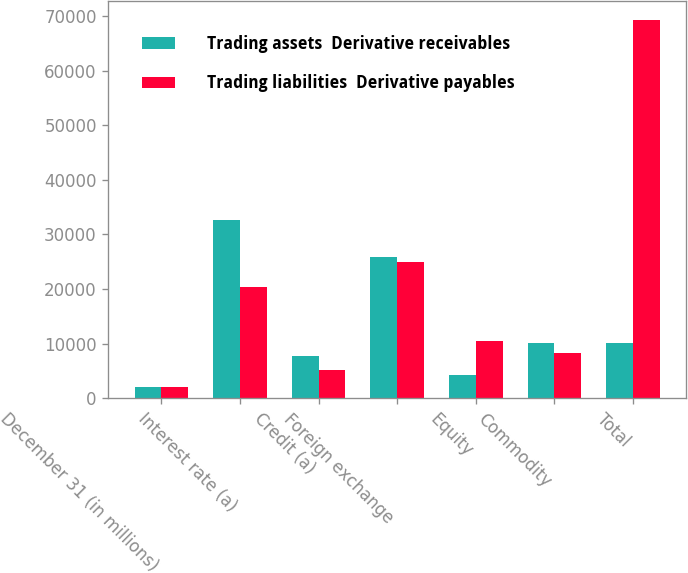Convert chart. <chart><loc_0><loc_0><loc_500><loc_500><stacked_bar_chart><ecel><fcel>December 31 (in millions)<fcel>Interest rate (a)<fcel>Credit (a)<fcel>Foreign exchange<fcel>Equity<fcel>Commodity<fcel>Total<nl><fcel>Trading assets  Derivative receivables<fcel>2010<fcel>32555<fcel>7725<fcel>25858<fcel>4204<fcel>10139<fcel>10139<nl><fcel>Trading liabilities  Derivative payables<fcel>2010<fcel>20387<fcel>5138<fcel>25015<fcel>10450<fcel>8229<fcel>69219<nl></chart> 